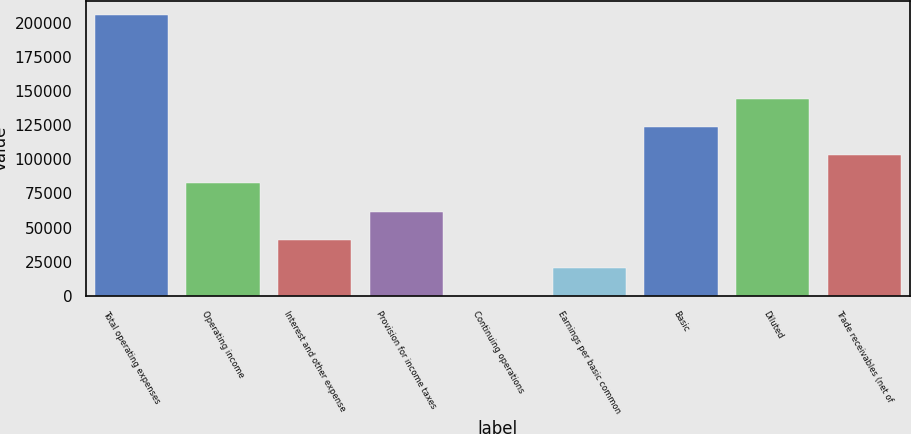<chart> <loc_0><loc_0><loc_500><loc_500><bar_chart><fcel>Total operating expenses<fcel>Operating income<fcel>Interest and other expense<fcel>Provision for income taxes<fcel>Continuing operations<fcel>Earnings per basic common<fcel>Basic<fcel>Diluted<fcel>Trade receivables (net of<nl><fcel>205567<fcel>82227.2<fcel>41113.9<fcel>61670.5<fcel>0.6<fcel>20557.2<fcel>123340<fcel>143897<fcel>102784<nl></chart> 